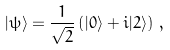Convert formula to latex. <formula><loc_0><loc_0><loc_500><loc_500>| \psi \rangle = \frac { 1 } { \sqrt { 2 } } \left ( | 0 \rangle + i | 2 \rangle \right ) \, ,</formula> 